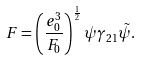Convert formula to latex. <formula><loc_0><loc_0><loc_500><loc_500>F = \left ( \frac { e _ { 0 } ^ { 3 } } { F _ { 0 } } \right ) ^ { \frac { 1 } { 2 } } \psi \gamma _ { 2 1 } \tilde { \psi } .</formula> 